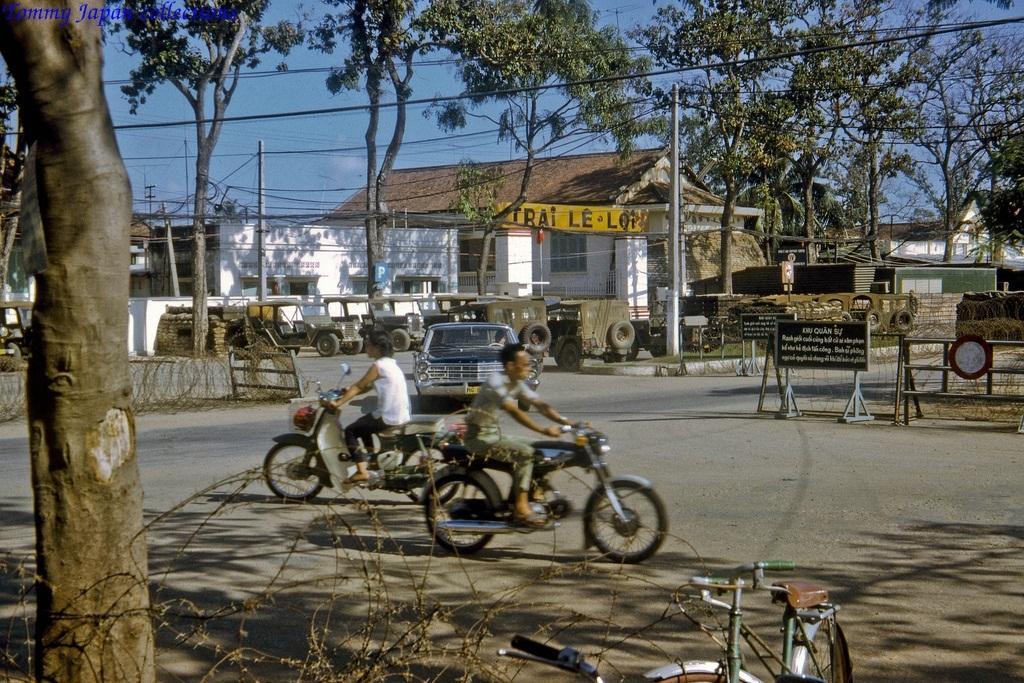Describe this image in one or two sentences. In this image I can see two persons riding bicycles on the road. On the left of this image I can see a tree, in the background also there are some trees. On the top of this image I can see the sky in blue color. In the middle there is a house and there are some some vehicles in front in this house. On the right side I can see some boards having some instructions on it. 